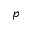Convert formula to latex. <formula><loc_0><loc_0><loc_500><loc_500>p</formula> 